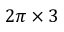<formula> <loc_0><loc_0><loc_500><loc_500>2 \pi \times 3</formula> 